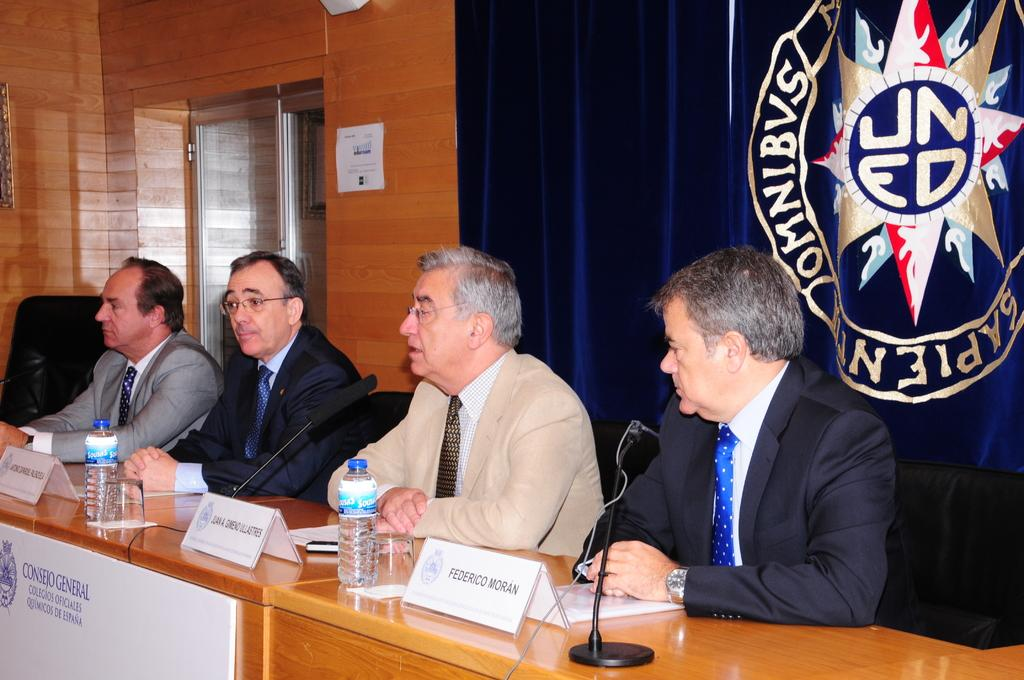<image>
Write a terse but informative summary of the picture. a group of guys talking with a UNED sign behind them 